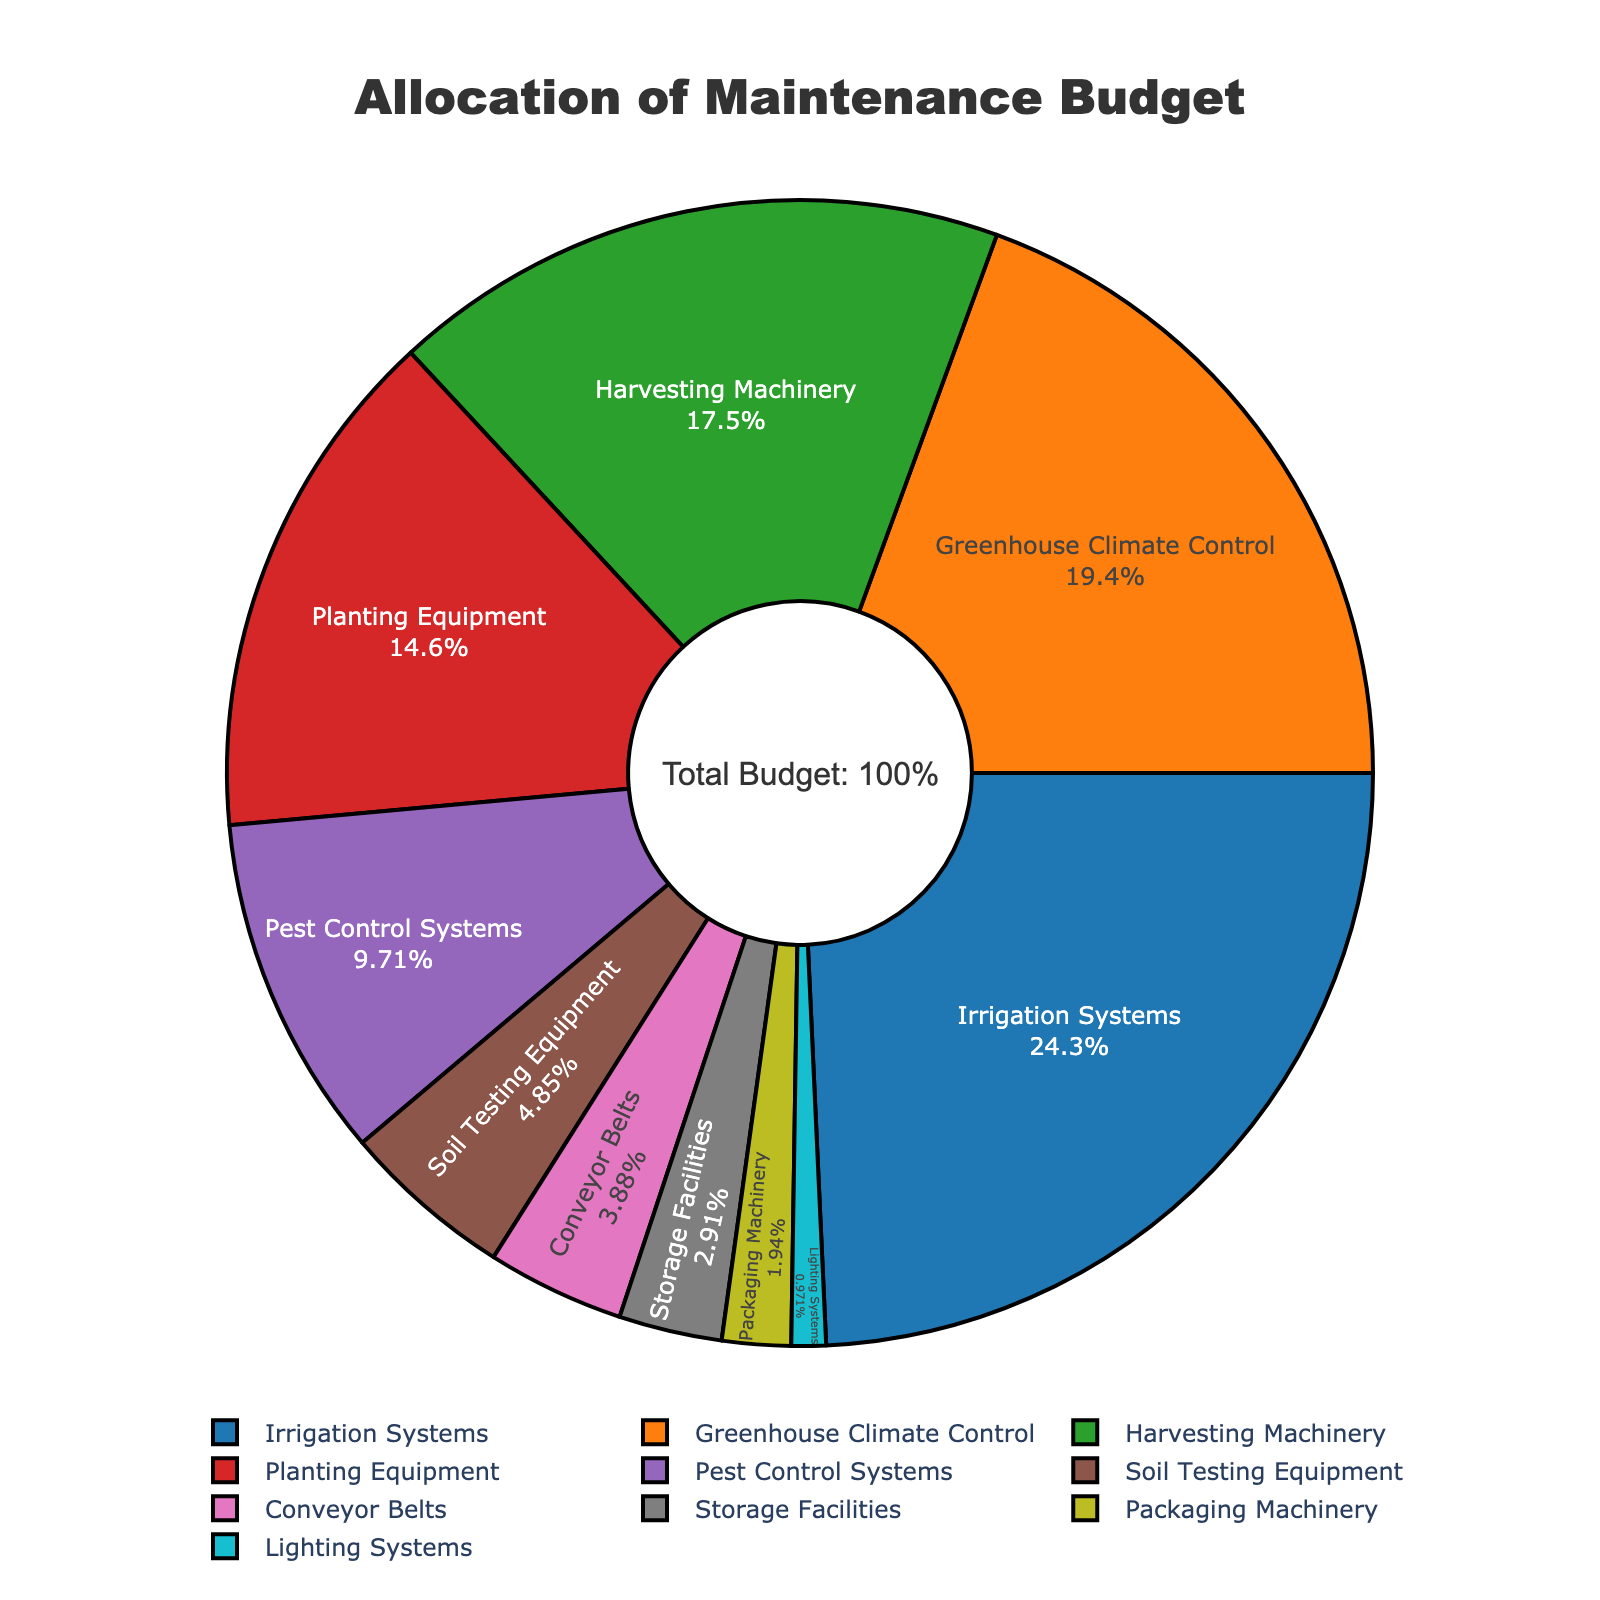Which equipment type has the highest budget allocation percentage? The pie chart indicates that Irrigation Systems have the largest segment with a percentage of 25%.
Answer: Irrigation Systems What is the combined budget allocation percentage for Harvesting Machinery and Planting Equipment? The budget allocation for Harvesting Machinery is 18%, and for Planting Equipment, it is 15%. Adding these together, 18% + 15% = 33%.
Answer: 33% How does the budget allocation for Pest Control Systems compare to that of Greenhouse Climate Control? The budget allocation for Pest Control Systems is 10%, while for Greenhouse Climate Control, it is 20%. Comparatively, Pest Control Systems have half the budget allocation of Greenhouse Climate Control.
Answer: Pest Control Systems have half the allocation of Greenhouse Climate Control Are there more equipment types with budget allocations greater than 10% or less than 10%? Analyzing the pie chart, equipment types with greater than 10% are Irrigation Systems, Greenhouse Climate Control, Harvesting Machinery, and Planting Equipment (4 types). Those with less than 10% are Pest Control Systems, Soil Testing Equipment, Conveyor Belts, Storage Facilities, Packaging Machinery, and Lighting Systems (6 types).
Answer: Less than 10% What is the budget allocation difference between the highest and lowest allocated equipment types? The highest allocation is for Irrigation Systems at 25%, and the lowest is for Lighting Systems at 1%. The difference is 25% - 1% = 24%.
Answer: 24% Which equipment type shares the closest budget allocation to that of Packaging Machinery, and what is that percentage? Packaging Machinery has a budget allocation of 2%. Conveyor Belts have a budget allocation of 4%, which is the closest to 2%.
Answer: Conveyor Belts, 4% What proportion of the budget is allocated to equipment types involved in pest and soil management? The allocation for Pest Control Systems is 10%, and for Soil Testing Equipment, it is 5%. Combining these gives 10% + 5% = 15%.
Answer: 15% Is the budget allocation for Harvesting Machinery more than double that for Storage Facilities? The allocation for Harvesting Machinery is 18%, and for Storage Facilities, it is 3%. Doubling 3% gives 6%, and 18% is more than double 6%.
Answer: Yes What is the average budget allocation percentage for all equipment types? Adding all percentages together, we get 25 + 20 + 18 + 15 + 10 + 5 + 4 + 3 + 2 + 1 = 103. The average percentage is 103 / 10 = 10.3%.
Answer: 10.3% How does the total budget allocation for Irrigation Systems, Greenhouse Climate Control, and Harvesting Machinery compare to the combined allocation for all other equipment types? The combined allocation for Irrigation Systems, Greenhouse Climate Control, and Harvesting Machinery is 25% + 20% + 18% = 63%. The total allocation for all other types (including Planting Equipment, Pest Control Systems, etc.) adds up to 10% + 5% + 4% + 3% + 2% + 1% = 25%.
Answer: 63% vs 25% 